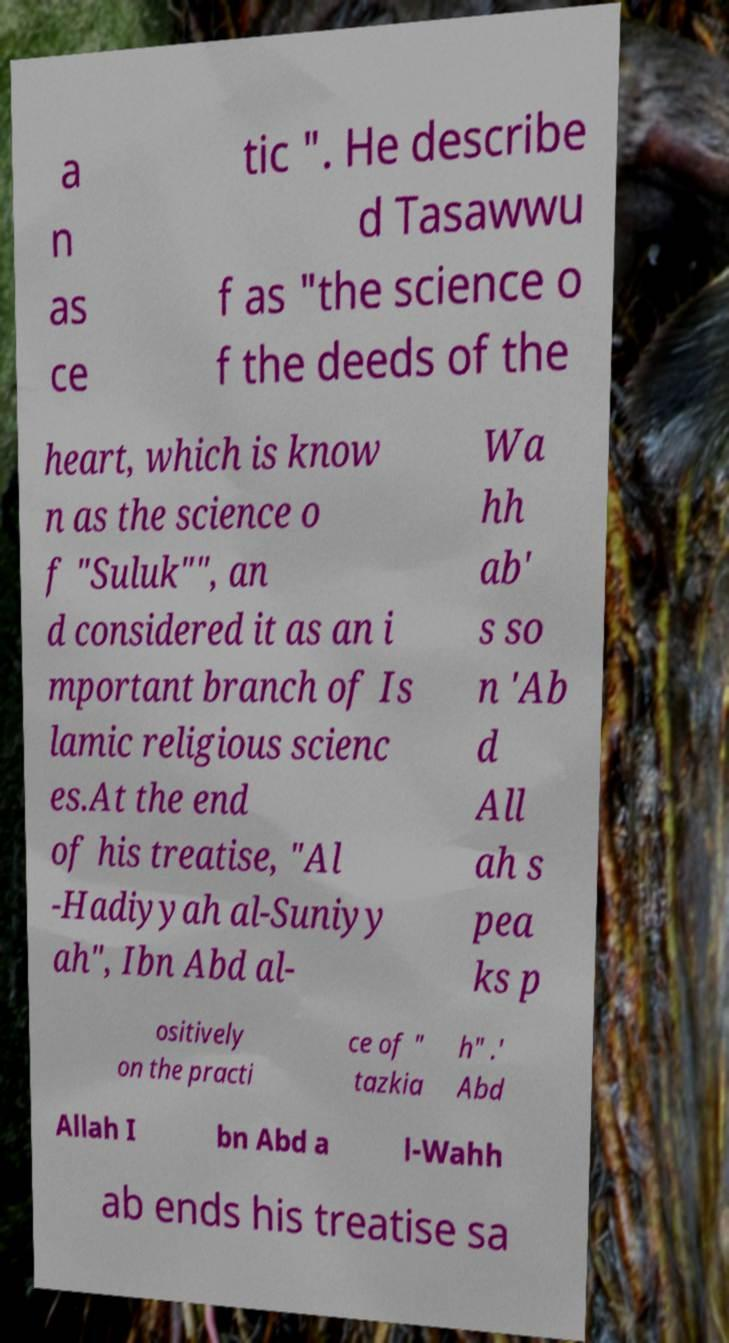There's text embedded in this image that I need extracted. Can you transcribe it verbatim? a n as ce tic ". He describe d Tasawwu f as "the science o f the deeds of the heart, which is know n as the science o f "Suluk"", an d considered it as an i mportant branch of Is lamic religious scienc es.At the end of his treatise, "Al -Hadiyyah al-Suniyy ah", Ibn Abd al- Wa hh ab' s so n 'Ab d All ah s pea ks p ositively on the practi ce of " tazkia h" .' Abd Allah I bn Abd a l-Wahh ab ends his treatise sa 